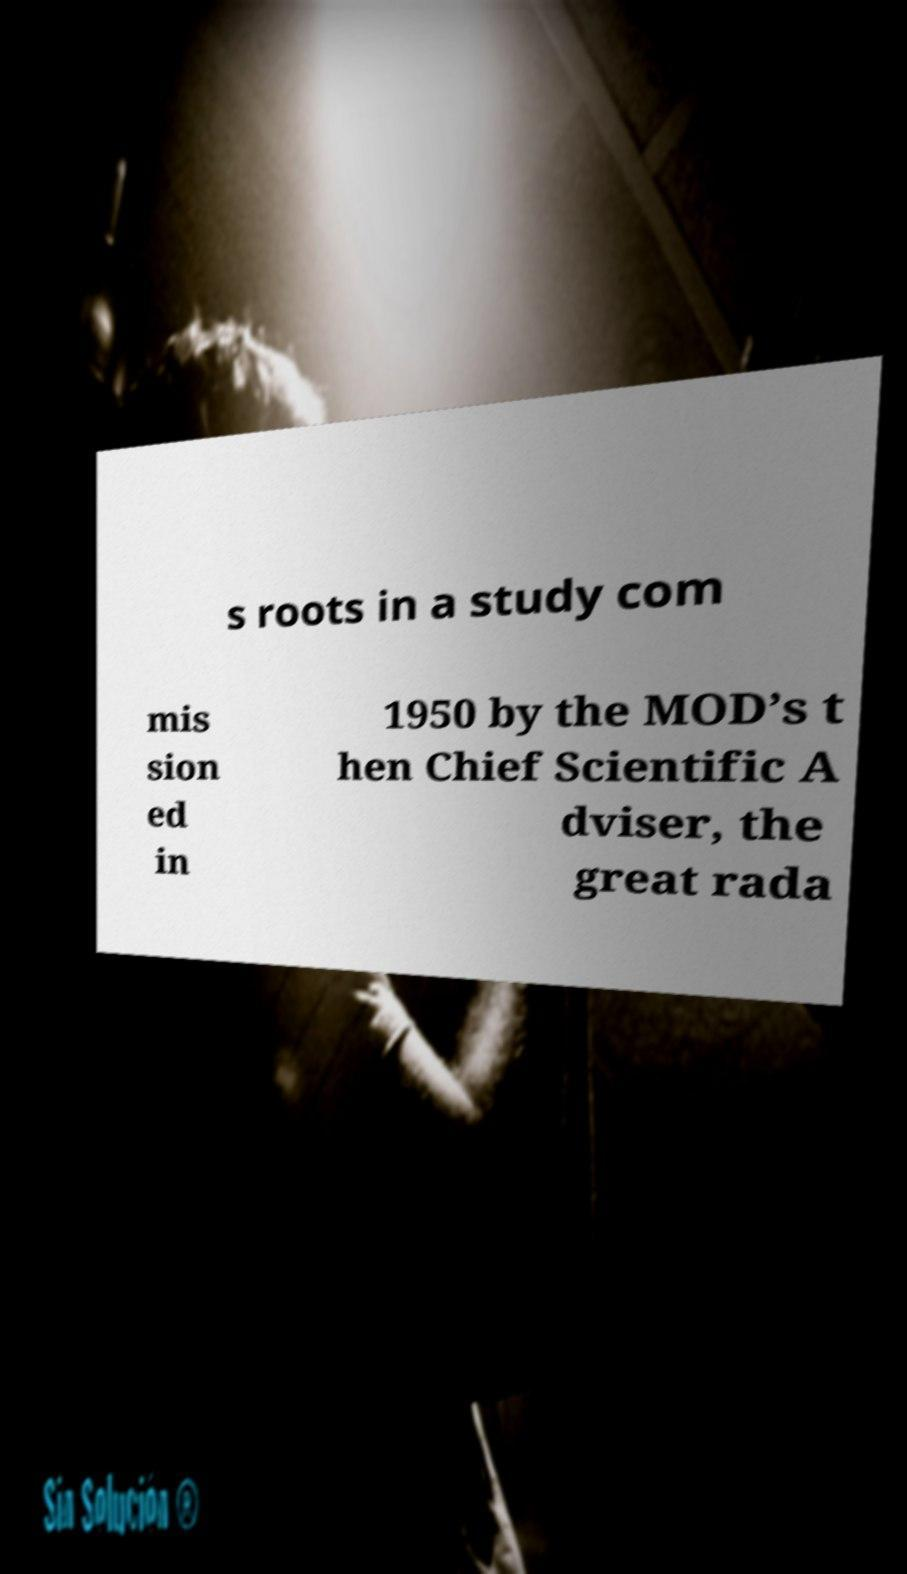What messages or text are displayed in this image? I need them in a readable, typed format. s roots in a study com mis sion ed in 1950 by the MOD’s t hen Chief Scientific A dviser, the great rada 